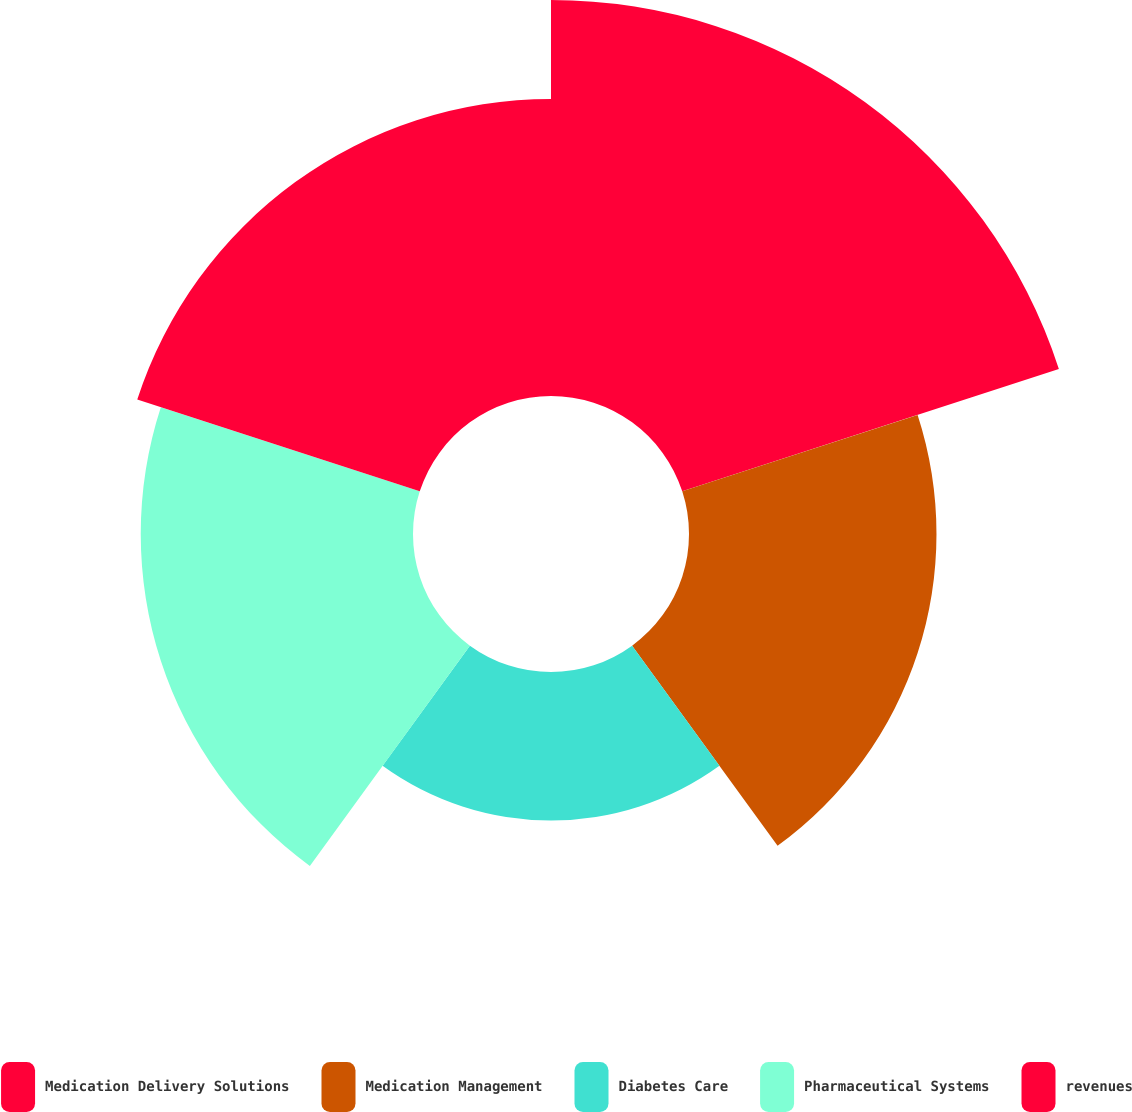<chart> <loc_0><loc_0><loc_500><loc_500><pie_chart><fcel>Medication Delivery Solutions<fcel>Medication Management<fcel>Diabetes Care<fcel>Pharmaceutical Systems<fcel>revenues<nl><fcel>29.09%<fcel>18.18%<fcel>10.91%<fcel>20.0%<fcel>21.82%<nl></chart> 